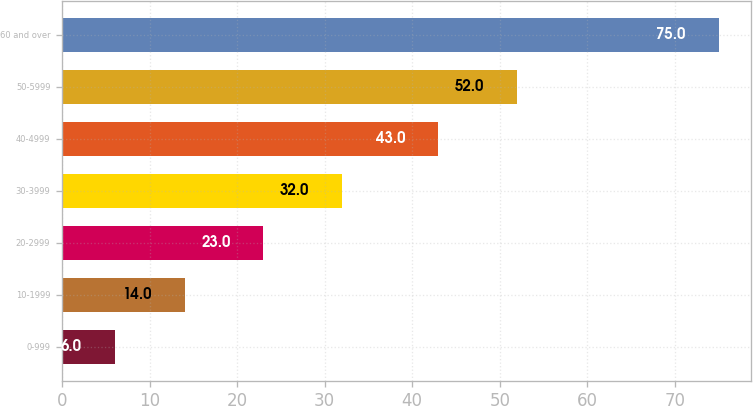Convert chart. <chart><loc_0><loc_0><loc_500><loc_500><bar_chart><fcel>0-999<fcel>10-1999<fcel>20-2999<fcel>30-3999<fcel>40-4999<fcel>50-5999<fcel>60 and over<nl><fcel>6<fcel>14<fcel>23<fcel>32<fcel>43<fcel>52<fcel>75<nl></chart> 